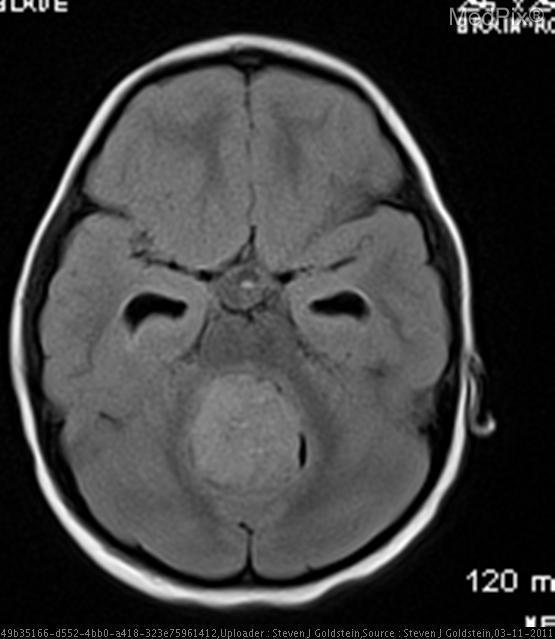In what ventricle is the enhancing intraventricular mass seen?
Short answer required. 4th ventricle. Does this patient have a skull fracture?
Answer briefly. No. Does this image display the cns?
Be succinct. Yes. Does this image display hydrocephalus?
Keep it brief. Yes. In what plane is this mri taken?
Keep it brief. Axial. Is this an mri?
Be succinct. Yes. 